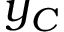Convert formula to latex. <formula><loc_0><loc_0><loc_500><loc_500>y _ { C }</formula> 